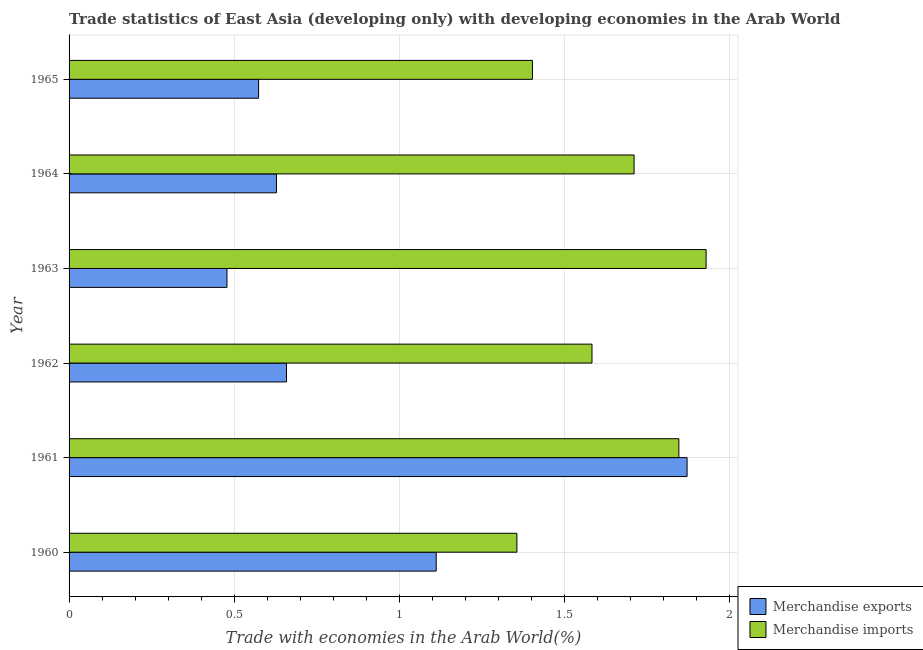How many different coloured bars are there?
Keep it short and to the point. 2. Are the number of bars on each tick of the Y-axis equal?
Your answer should be compact. Yes. What is the label of the 1st group of bars from the top?
Your answer should be compact. 1965. What is the merchandise exports in 1960?
Your answer should be very brief. 1.11. Across all years, what is the maximum merchandise exports?
Your answer should be very brief. 1.87. Across all years, what is the minimum merchandise exports?
Your answer should be very brief. 0.48. What is the total merchandise exports in the graph?
Provide a succinct answer. 5.32. What is the difference between the merchandise exports in 1960 and that in 1961?
Your answer should be compact. -0.76. What is the difference between the merchandise imports in 1962 and the merchandise exports in 1961?
Offer a terse response. -0.29. What is the average merchandise imports per year?
Offer a very short reply. 1.64. In the year 1961, what is the difference between the merchandise imports and merchandise exports?
Your answer should be compact. -0.03. What is the ratio of the merchandise exports in 1960 to that in 1961?
Your answer should be compact. 0.59. Is the merchandise exports in 1961 less than that in 1963?
Make the answer very short. No. What is the difference between the highest and the second highest merchandise exports?
Offer a terse response. 0.76. What is the difference between the highest and the lowest merchandise imports?
Ensure brevity in your answer.  0.57. How many bars are there?
Your answer should be very brief. 12. What is the difference between two consecutive major ticks on the X-axis?
Your answer should be compact. 0.5. Does the graph contain any zero values?
Keep it short and to the point. No. Does the graph contain grids?
Offer a terse response. Yes. How many legend labels are there?
Offer a terse response. 2. How are the legend labels stacked?
Make the answer very short. Vertical. What is the title of the graph?
Your response must be concise. Trade statistics of East Asia (developing only) with developing economies in the Arab World. What is the label or title of the X-axis?
Offer a very short reply. Trade with economies in the Arab World(%). What is the label or title of the Y-axis?
Keep it short and to the point. Year. What is the Trade with economies in the Arab World(%) of Merchandise exports in 1960?
Provide a succinct answer. 1.11. What is the Trade with economies in the Arab World(%) in Merchandise imports in 1960?
Your answer should be compact. 1.36. What is the Trade with economies in the Arab World(%) of Merchandise exports in 1961?
Your answer should be compact. 1.87. What is the Trade with economies in the Arab World(%) in Merchandise imports in 1961?
Make the answer very short. 1.85. What is the Trade with economies in the Arab World(%) in Merchandise exports in 1962?
Your response must be concise. 0.66. What is the Trade with economies in the Arab World(%) of Merchandise imports in 1962?
Offer a terse response. 1.58. What is the Trade with economies in the Arab World(%) in Merchandise exports in 1963?
Keep it short and to the point. 0.48. What is the Trade with economies in the Arab World(%) of Merchandise imports in 1963?
Make the answer very short. 1.93. What is the Trade with economies in the Arab World(%) in Merchandise exports in 1964?
Your answer should be very brief. 0.63. What is the Trade with economies in the Arab World(%) of Merchandise imports in 1964?
Your response must be concise. 1.71. What is the Trade with economies in the Arab World(%) in Merchandise exports in 1965?
Keep it short and to the point. 0.57. What is the Trade with economies in the Arab World(%) in Merchandise imports in 1965?
Offer a terse response. 1.4. Across all years, what is the maximum Trade with economies in the Arab World(%) in Merchandise exports?
Keep it short and to the point. 1.87. Across all years, what is the maximum Trade with economies in the Arab World(%) of Merchandise imports?
Offer a terse response. 1.93. Across all years, what is the minimum Trade with economies in the Arab World(%) of Merchandise exports?
Ensure brevity in your answer.  0.48. Across all years, what is the minimum Trade with economies in the Arab World(%) in Merchandise imports?
Your answer should be compact. 1.36. What is the total Trade with economies in the Arab World(%) of Merchandise exports in the graph?
Provide a succinct answer. 5.32. What is the total Trade with economies in the Arab World(%) of Merchandise imports in the graph?
Your answer should be compact. 9.83. What is the difference between the Trade with economies in the Arab World(%) of Merchandise exports in 1960 and that in 1961?
Offer a very short reply. -0.76. What is the difference between the Trade with economies in the Arab World(%) in Merchandise imports in 1960 and that in 1961?
Offer a terse response. -0.49. What is the difference between the Trade with economies in the Arab World(%) of Merchandise exports in 1960 and that in 1962?
Provide a short and direct response. 0.45. What is the difference between the Trade with economies in the Arab World(%) in Merchandise imports in 1960 and that in 1962?
Give a very brief answer. -0.23. What is the difference between the Trade with economies in the Arab World(%) in Merchandise exports in 1960 and that in 1963?
Give a very brief answer. 0.63. What is the difference between the Trade with economies in the Arab World(%) of Merchandise imports in 1960 and that in 1963?
Provide a short and direct response. -0.57. What is the difference between the Trade with economies in the Arab World(%) of Merchandise exports in 1960 and that in 1964?
Provide a succinct answer. 0.48. What is the difference between the Trade with economies in the Arab World(%) of Merchandise imports in 1960 and that in 1964?
Make the answer very short. -0.35. What is the difference between the Trade with economies in the Arab World(%) in Merchandise exports in 1960 and that in 1965?
Provide a succinct answer. 0.54. What is the difference between the Trade with economies in the Arab World(%) of Merchandise imports in 1960 and that in 1965?
Your answer should be very brief. -0.05. What is the difference between the Trade with economies in the Arab World(%) in Merchandise exports in 1961 and that in 1962?
Your response must be concise. 1.21. What is the difference between the Trade with economies in the Arab World(%) of Merchandise imports in 1961 and that in 1962?
Your answer should be very brief. 0.26. What is the difference between the Trade with economies in the Arab World(%) of Merchandise exports in 1961 and that in 1963?
Ensure brevity in your answer.  1.39. What is the difference between the Trade with economies in the Arab World(%) in Merchandise imports in 1961 and that in 1963?
Offer a terse response. -0.08. What is the difference between the Trade with economies in the Arab World(%) in Merchandise exports in 1961 and that in 1964?
Give a very brief answer. 1.24. What is the difference between the Trade with economies in the Arab World(%) of Merchandise imports in 1961 and that in 1964?
Offer a terse response. 0.14. What is the difference between the Trade with economies in the Arab World(%) in Merchandise exports in 1961 and that in 1965?
Offer a terse response. 1.3. What is the difference between the Trade with economies in the Arab World(%) in Merchandise imports in 1961 and that in 1965?
Keep it short and to the point. 0.44. What is the difference between the Trade with economies in the Arab World(%) in Merchandise exports in 1962 and that in 1963?
Provide a succinct answer. 0.18. What is the difference between the Trade with economies in the Arab World(%) in Merchandise imports in 1962 and that in 1963?
Make the answer very short. -0.35. What is the difference between the Trade with economies in the Arab World(%) of Merchandise exports in 1962 and that in 1964?
Ensure brevity in your answer.  0.03. What is the difference between the Trade with economies in the Arab World(%) of Merchandise imports in 1962 and that in 1964?
Ensure brevity in your answer.  -0.13. What is the difference between the Trade with economies in the Arab World(%) in Merchandise exports in 1962 and that in 1965?
Make the answer very short. 0.08. What is the difference between the Trade with economies in the Arab World(%) of Merchandise imports in 1962 and that in 1965?
Your answer should be compact. 0.18. What is the difference between the Trade with economies in the Arab World(%) of Merchandise exports in 1963 and that in 1964?
Your answer should be compact. -0.15. What is the difference between the Trade with economies in the Arab World(%) in Merchandise imports in 1963 and that in 1964?
Offer a very short reply. 0.22. What is the difference between the Trade with economies in the Arab World(%) in Merchandise exports in 1963 and that in 1965?
Provide a short and direct response. -0.1. What is the difference between the Trade with economies in the Arab World(%) in Merchandise imports in 1963 and that in 1965?
Offer a very short reply. 0.53. What is the difference between the Trade with economies in the Arab World(%) of Merchandise exports in 1964 and that in 1965?
Offer a terse response. 0.05. What is the difference between the Trade with economies in the Arab World(%) of Merchandise imports in 1964 and that in 1965?
Provide a short and direct response. 0.31. What is the difference between the Trade with economies in the Arab World(%) in Merchandise exports in 1960 and the Trade with economies in the Arab World(%) in Merchandise imports in 1961?
Provide a short and direct response. -0.73. What is the difference between the Trade with economies in the Arab World(%) of Merchandise exports in 1960 and the Trade with economies in the Arab World(%) of Merchandise imports in 1962?
Offer a terse response. -0.47. What is the difference between the Trade with economies in the Arab World(%) of Merchandise exports in 1960 and the Trade with economies in the Arab World(%) of Merchandise imports in 1963?
Your answer should be very brief. -0.82. What is the difference between the Trade with economies in the Arab World(%) in Merchandise exports in 1960 and the Trade with economies in the Arab World(%) in Merchandise imports in 1964?
Make the answer very short. -0.6. What is the difference between the Trade with economies in the Arab World(%) of Merchandise exports in 1960 and the Trade with economies in the Arab World(%) of Merchandise imports in 1965?
Make the answer very short. -0.29. What is the difference between the Trade with economies in the Arab World(%) in Merchandise exports in 1961 and the Trade with economies in the Arab World(%) in Merchandise imports in 1962?
Provide a succinct answer. 0.29. What is the difference between the Trade with economies in the Arab World(%) in Merchandise exports in 1961 and the Trade with economies in the Arab World(%) in Merchandise imports in 1963?
Provide a short and direct response. -0.06. What is the difference between the Trade with economies in the Arab World(%) of Merchandise exports in 1961 and the Trade with economies in the Arab World(%) of Merchandise imports in 1964?
Offer a terse response. 0.16. What is the difference between the Trade with economies in the Arab World(%) in Merchandise exports in 1961 and the Trade with economies in the Arab World(%) in Merchandise imports in 1965?
Offer a terse response. 0.47. What is the difference between the Trade with economies in the Arab World(%) in Merchandise exports in 1962 and the Trade with economies in the Arab World(%) in Merchandise imports in 1963?
Provide a short and direct response. -1.27. What is the difference between the Trade with economies in the Arab World(%) in Merchandise exports in 1962 and the Trade with economies in the Arab World(%) in Merchandise imports in 1964?
Provide a short and direct response. -1.05. What is the difference between the Trade with economies in the Arab World(%) in Merchandise exports in 1962 and the Trade with economies in the Arab World(%) in Merchandise imports in 1965?
Keep it short and to the point. -0.74. What is the difference between the Trade with economies in the Arab World(%) in Merchandise exports in 1963 and the Trade with economies in the Arab World(%) in Merchandise imports in 1964?
Ensure brevity in your answer.  -1.23. What is the difference between the Trade with economies in the Arab World(%) of Merchandise exports in 1963 and the Trade with economies in the Arab World(%) of Merchandise imports in 1965?
Offer a very short reply. -0.92. What is the difference between the Trade with economies in the Arab World(%) in Merchandise exports in 1964 and the Trade with economies in the Arab World(%) in Merchandise imports in 1965?
Give a very brief answer. -0.78. What is the average Trade with economies in the Arab World(%) in Merchandise exports per year?
Give a very brief answer. 0.89. What is the average Trade with economies in the Arab World(%) in Merchandise imports per year?
Your answer should be very brief. 1.64. In the year 1960, what is the difference between the Trade with economies in the Arab World(%) in Merchandise exports and Trade with economies in the Arab World(%) in Merchandise imports?
Your answer should be very brief. -0.24. In the year 1961, what is the difference between the Trade with economies in the Arab World(%) in Merchandise exports and Trade with economies in the Arab World(%) in Merchandise imports?
Provide a succinct answer. 0.02. In the year 1962, what is the difference between the Trade with economies in the Arab World(%) of Merchandise exports and Trade with economies in the Arab World(%) of Merchandise imports?
Ensure brevity in your answer.  -0.92. In the year 1963, what is the difference between the Trade with economies in the Arab World(%) of Merchandise exports and Trade with economies in the Arab World(%) of Merchandise imports?
Your answer should be very brief. -1.45. In the year 1964, what is the difference between the Trade with economies in the Arab World(%) of Merchandise exports and Trade with economies in the Arab World(%) of Merchandise imports?
Provide a short and direct response. -1.08. In the year 1965, what is the difference between the Trade with economies in the Arab World(%) in Merchandise exports and Trade with economies in the Arab World(%) in Merchandise imports?
Offer a terse response. -0.83. What is the ratio of the Trade with economies in the Arab World(%) in Merchandise exports in 1960 to that in 1961?
Your answer should be very brief. 0.59. What is the ratio of the Trade with economies in the Arab World(%) of Merchandise imports in 1960 to that in 1961?
Offer a very short reply. 0.73. What is the ratio of the Trade with economies in the Arab World(%) of Merchandise exports in 1960 to that in 1962?
Keep it short and to the point. 1.69. What is the ratio of the Trade with economies in the Arab World(%) in Merchandise imports in 1960 to that in 1962?
Your answer should be very brief. 0.86. What is the ratio of the Trade with economies in the Arab World(%) in Merchandise exports in 1960 to that in 1963?
Ensure brevity in your answer.  2.33. What is the ratio of the Trade with economies in the Arab World(%) in Merchandise imports in 1960 to that in 1963?
Offer a very short reply. 0.7. What is the ratio of the Trade with economies in the Arab World(%) in Merchandise exports in 1960 to that in 1964?
Offer a very short reply. 1.77. What is the ratio of the Trade with economies in the Arab World(%) of Merchandise imports in 1960 to that in 1964?
Your answer should be compact. 0.79. What is the ratio of the Trade with economies in the Arab World(%) of Merchandise exports in 1960 to that in 1965?
Your answer should be compact. 1.94. What is the ratio of the Trade with economies in the Arab World(%) in Merchandise imports in 1960 to that in 1965?
Your answer should be compact. 0.97. What is the ratio of the Trade with economies in the Arab World(%) in Merchandise exports in 1961 to that in 1962?
Make the answer very short. 2.84. What is the ratio of the Trade with economies in the Arab World(%) in Merchandise imports in 1961 to that in 1962?
Provide a succinct answer. 1.17. What is the ratio of the Trade with economies in the Arab World(%) of Merchandise exports in 1961 to that in 1963?
Your answer should be very brief. 3.91. What is the ratio of the Trade with economies in the Arab World(%) in Merchandise imports in 1961 to that in 1963?
Keep it short and to the point. 0.96. What is the ratio of the Trade with economies in the Arab World(%) of Merchandise exports in 1961 to that in 1964?
Offer a very short reply. 2.98. What is the ratio of the Trade with economies in the Arab World(%) in Merchandise imports in 1961 to that in 1964?
Your answer should be very brief. 1.08. What is the ratio of the Trade with economies in the Arab World(%) of Merchandise exports in 1961 to that in 1965?
Your response must be concise. 3.26. What is the ratio of the Trade with economies in the Arab World(%) of Merchandise imports in 1961 to that in 1965?
Offer a terse response. 1.32. What is the ratio of the Trade with economies in the Arab World(%) in Merchandise exports in 1962 to that in 1963?
Keep it short and to the point. 1.38. What is the ratio of the Trade with economies in the Arab World(%) in Merchandise imports in 1962 to that in 1963?
Provide a succinct answer. 0.82. What is the ratio of the Trade with economies in the Arab World(%) of Merchandise exports in 1962 to that in 1964?
Provide a short and direct response. 1.05. What is the ratio of the Trade with economies in the Arab World(%) of Merchandise imports in 1962 to that in 1964?
Give a very brief answer. 0.93. What is the ratio of the Trade with economies in the Arab World(%) in Merchandise exports in 1962 to that in 1965?
Make the answer very short. 1.15. What is the ratio of the Trade with economies in the Arab World(%) in Merchandise imports in 1962 to that in 1965?
Provide a short and direct response. 1.13. What is the ratio of the Trade with economies in the Arab World(%) of Merchandise exports in 1963 to that in 1964?
Provide a succinct answer. 0.76. What is the ratio of the Trade with economies in the Arab World(%) in Merchandise imports in 1963 to that in 1964?
Your response must be concise. 1.13. What is the ratio of the Trade with economies in the Arab World(%) of Merchandise exports in 1963 to that in 1965?
Keep it short and to the point. 0.83. What is the ratio of the Trade with economies in the Arab World(%) in Merchandise imports in 1963 to that in 1965?
Your answer should be very brief. 1.37. What is the ratio of the Trade with economies in the Arab World(%) in Merchandise exports in 1964 to that in 1965?
Make the answer very short. 1.09. What is the ratio of the Trade with economies in the Arab World(%) of Merchandise imports in 1964 to that in 1965?
Keep it short and to the point. 1.22. What is the difference between the highest and the second highest Trade with economies in the Arab World(%) in Merchandise exports?
Make the answer very short. 0.76. What is the difference between the highest and the second highest Trade with economies in the Arab World(%) in Merchandise imports?
Your response must be concise. 0.08. What is the difference between the highest and the lowest Trade with economies in the Arab World(%) of Merchandise exports?
Give a very brief answer. 1.39. What is the difference between the highest and the lowest Trade with economies in the Arab World(%) of Merchandise imports?
Your response must be concise. 0.57. 